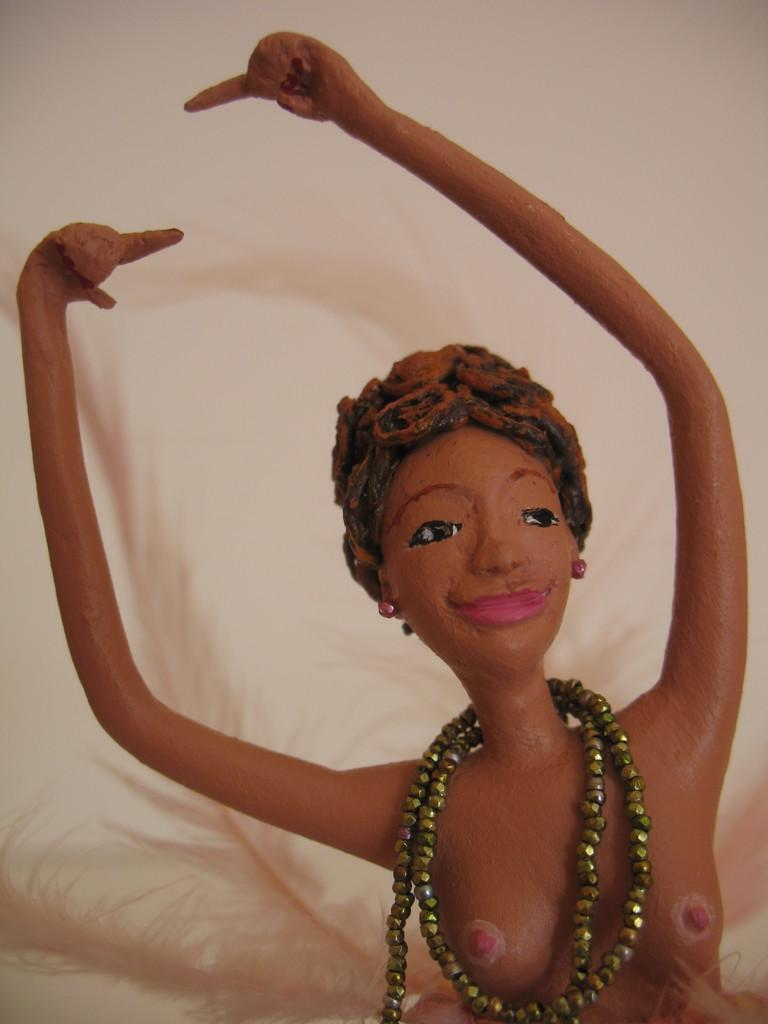What is the main subject of the image? There is a person statue in the image. What color is the statue? The statue is brown in color. What color is the background of the image? The background of the image is cream in color. What type of coast can be seen in the image? There is no coast visible in the image; it features a person statue with a cream-colored background. 